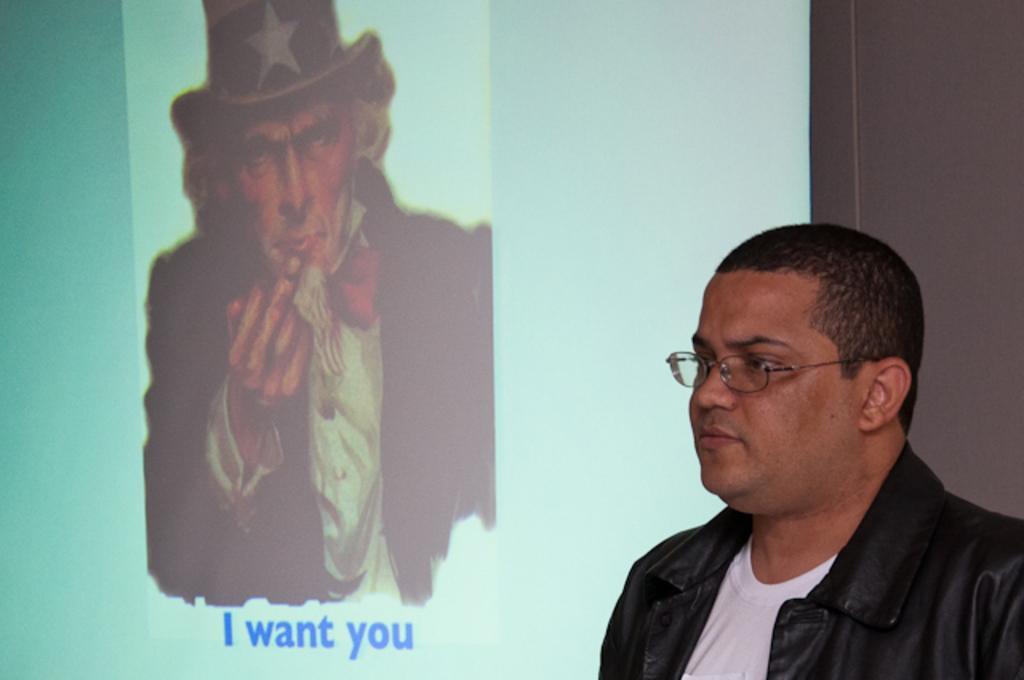Describe this image in one or two sentences. In the bottom right corner of the image a person is standing. Behind him there is a wall, on the wall there is a screen. In the screen we can see a person and alphabets. 